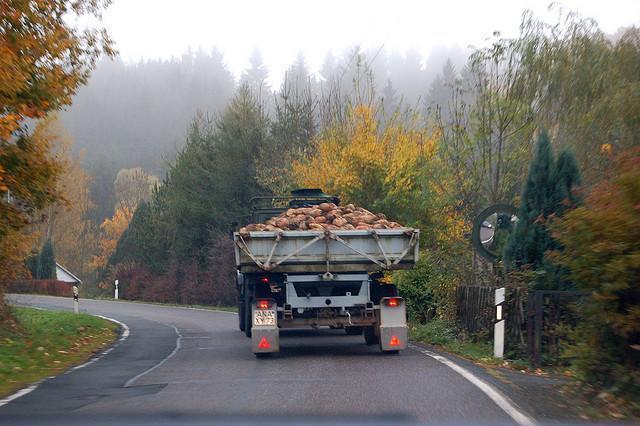How many vehicles are in the picture?
Give a very brief answer. 1. How many cars do you see?
Give a very brief answer. 1. 